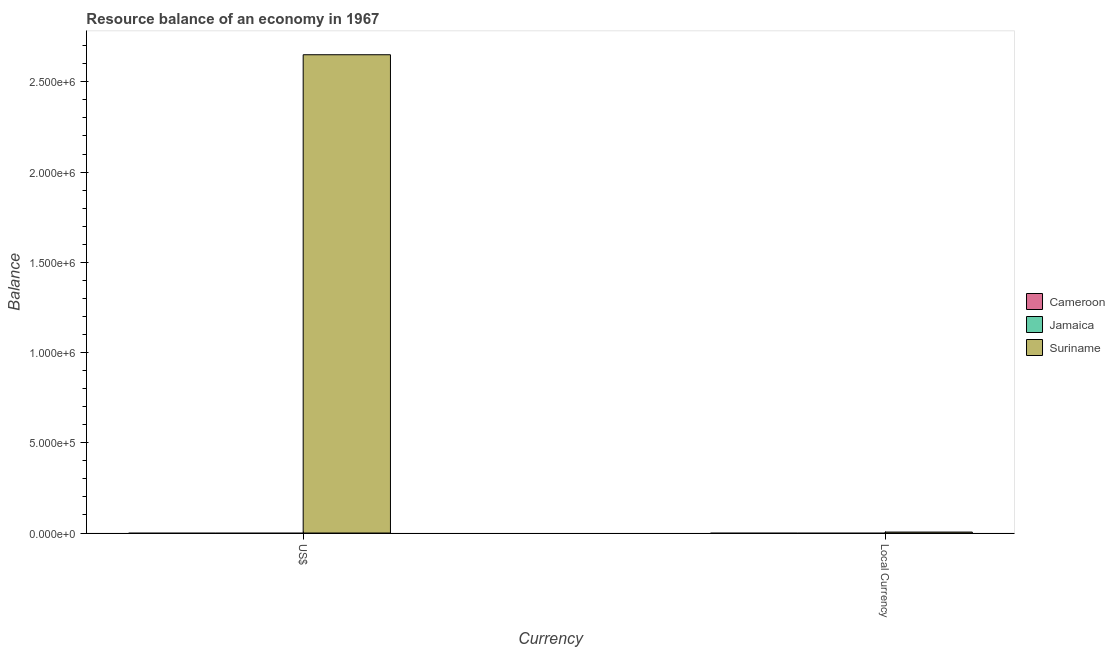How many bars are there on the 1st tick from the left?
Your answer should be compact. 1. What is the label of the 2nd group of bars from the left?
Give a very brief answer. Local Currency. What is the resource balance in us$ in Cameroon?
Offer a very short reply. 0. Across all countries, what is the maximum resource balance in constant us$?
Your answer should be compact. 5300. In which country was the resource balance in constant us$ maximum?
Your response must be concise. Suriname. What is the total resource balance in constant us$ in the graph?
Your answer should be compact. 5300. What is the average resource balance in constant us$ per country?
Keep it short and to the point. 1766.67. What is the difference between the resource balance in us$ and resource balance in constant us$ in Suriname?
Give a very brief answer. 2.64e+06. How many bars are there?
Provide a succinct answer. 2. Are the values on the major ticks of Y-axis written in scientific E-notation?
Your response must be concise. Yes. Does the graph contain any zero values?
Your answer should be compact. Yes. Where does the legend appear in the graph?
Make the answer very short. Center right. How many legend labels are there?
Provide a succinct answer. 3. How are the legend labels stacked?
Your answer should be compact. Vertical. What is the title of the graph?
Offer a terse response. Resource balance of an economy in 1967. What is the label or title of the X-axis?
Your answer should be compact. Currency. What is the label or title of the Y-axis?
Keep it short and to the point. Balance. What is the Balance of Jamaica in US$?
Keep it short and to the point. 0. What is the Balance of Suriname in US$?
Make the answer very short. 2.65e+06. What is the Balance in Cameroon in Local Currency?
Keep it short and to the point. 0. What is the Balance of Jamaica in Local Currency?
Your response must be concise. 0. What is the Balance of Suriname in Local Currency?
Make the answer very short. 5300. Across all Currency, what is the maximum Balance of Suriname?
Keep it short and to the point. 2.65e+06. Across all Currency, what is the minimum Balance of Suriname?
Your response must be concise. 5300. What is the total Balance in Suriname in the graph?
Your answer should be compact. 2.66e+06. What is the difference between the Balance in Suriname in US$ and that in Local Currency?
Your answer should be compact. 2.64e+06. What is the average Balance in Cameroon per Currency?
Your answer should be compact. 0. What is the average Balance in Jamaica per Currency?
Provide a succinct answer. 0. What is the average Balance in Suriname per Currency?
Offer a terse response. 1.33e+06. What is the ratio of the Balance of Suriname in US$ to that in Local Currency?
Make the answer very short. 500. What is the difference between the highest and the second highest Balance of Suriname?
Your answer should be compact. 2.64e+06. What is the difference between the highest and the lowest Balance of Suriname?
Your response must be concise. 2.64e+06. 